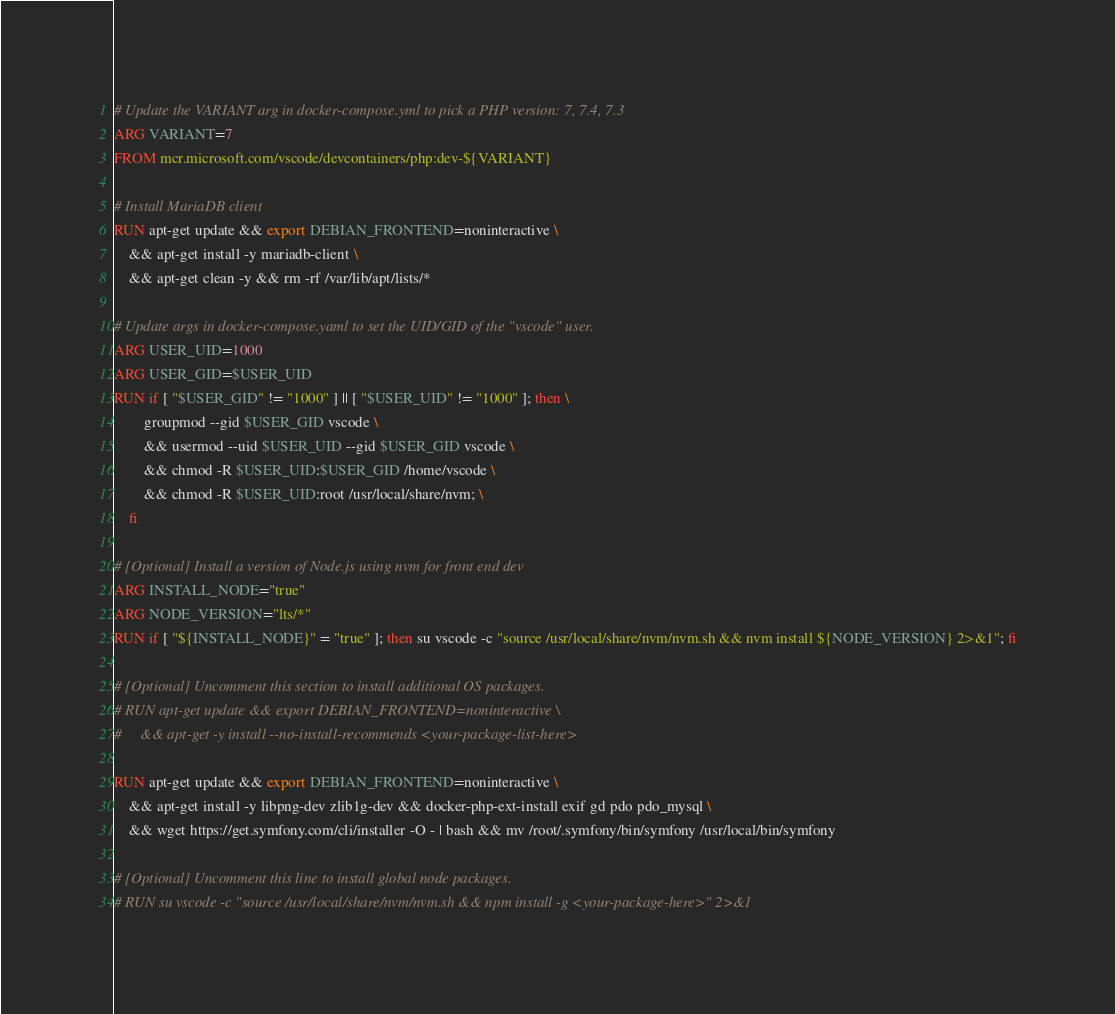<code> <loc_0><loc_0><loc_500><loc_500><_Dockerfile_># Update the VARIANT arg in docker-compose.yml to pick a PHP version: 7, 7.4, 7.3
ARG VARIANT=7
FROM mcr.microsoft.com/vscode/devcontainers/php:dev-${VARIANT}

# Install MariaDB client
RUN apt-get update && export DEBIAN_FRONTEND=noninteractive \
    && apt-get install -y mariadb-client \ 
    && apt-get clean -y && rm -rf /var/lib/apt/lists/*

# Update args in docker-compose.yaml to set the UID/GID of the "vscode" user.
ARG USER_UID=1000
ARG USER_GID=$USER_UID
RUN if [ "$USER_GID" != "1000" ] || [ "$USER_UID" != "1000" ]; then \
        groupmod --gid $USER_GID vscode \
        && usermod --uid $USER_UID --gid $USER_GID vscode \
        && chmod -R $USER_UID:$USER_GID /home/vscode \
        && chmod -R $USER_UID:root /usr/local/share/nvm; \
    fi

# [Optional] Install a version of Node.js using nvm for front end dev
ARG INSTALL_NODE="true"
ARG NODE_VERSION="lts/*"
RUN if [ "${INSTALL_NODE}" = "true" ]; then su vscode -c "source /usr/local/share/nvm/nvm.sh && nvm install ${NODE_VERSION} 2>&1"; fi

# [Optional] Uncomment this section to install additional OS packages.
# RUN apt-get update && export DEBIAN_FRONTEND=noninteractive \
#     && apt-get -y install --no-install-recommends <your-package-list-here>

RUN apt-get update && export DEBIAN_FRONTEND=noninteractive \
    && apt-get install -y libpng-dev zlib1g-dev && docker-php-ext-install exif gd pdo pdo_mysql \
    && wget https://get.symfony.com/cli/installer -O - | bash && mv /root/.symfony/bin/symfony /usr/local/bin/symfony

# [Optional] Uncomment this line to install global node packages.
# RUN su vscode -c "source /usr/local/share/nvm/nvm.sh && npm install -g <your-package-here>" 2>&1
</code> 